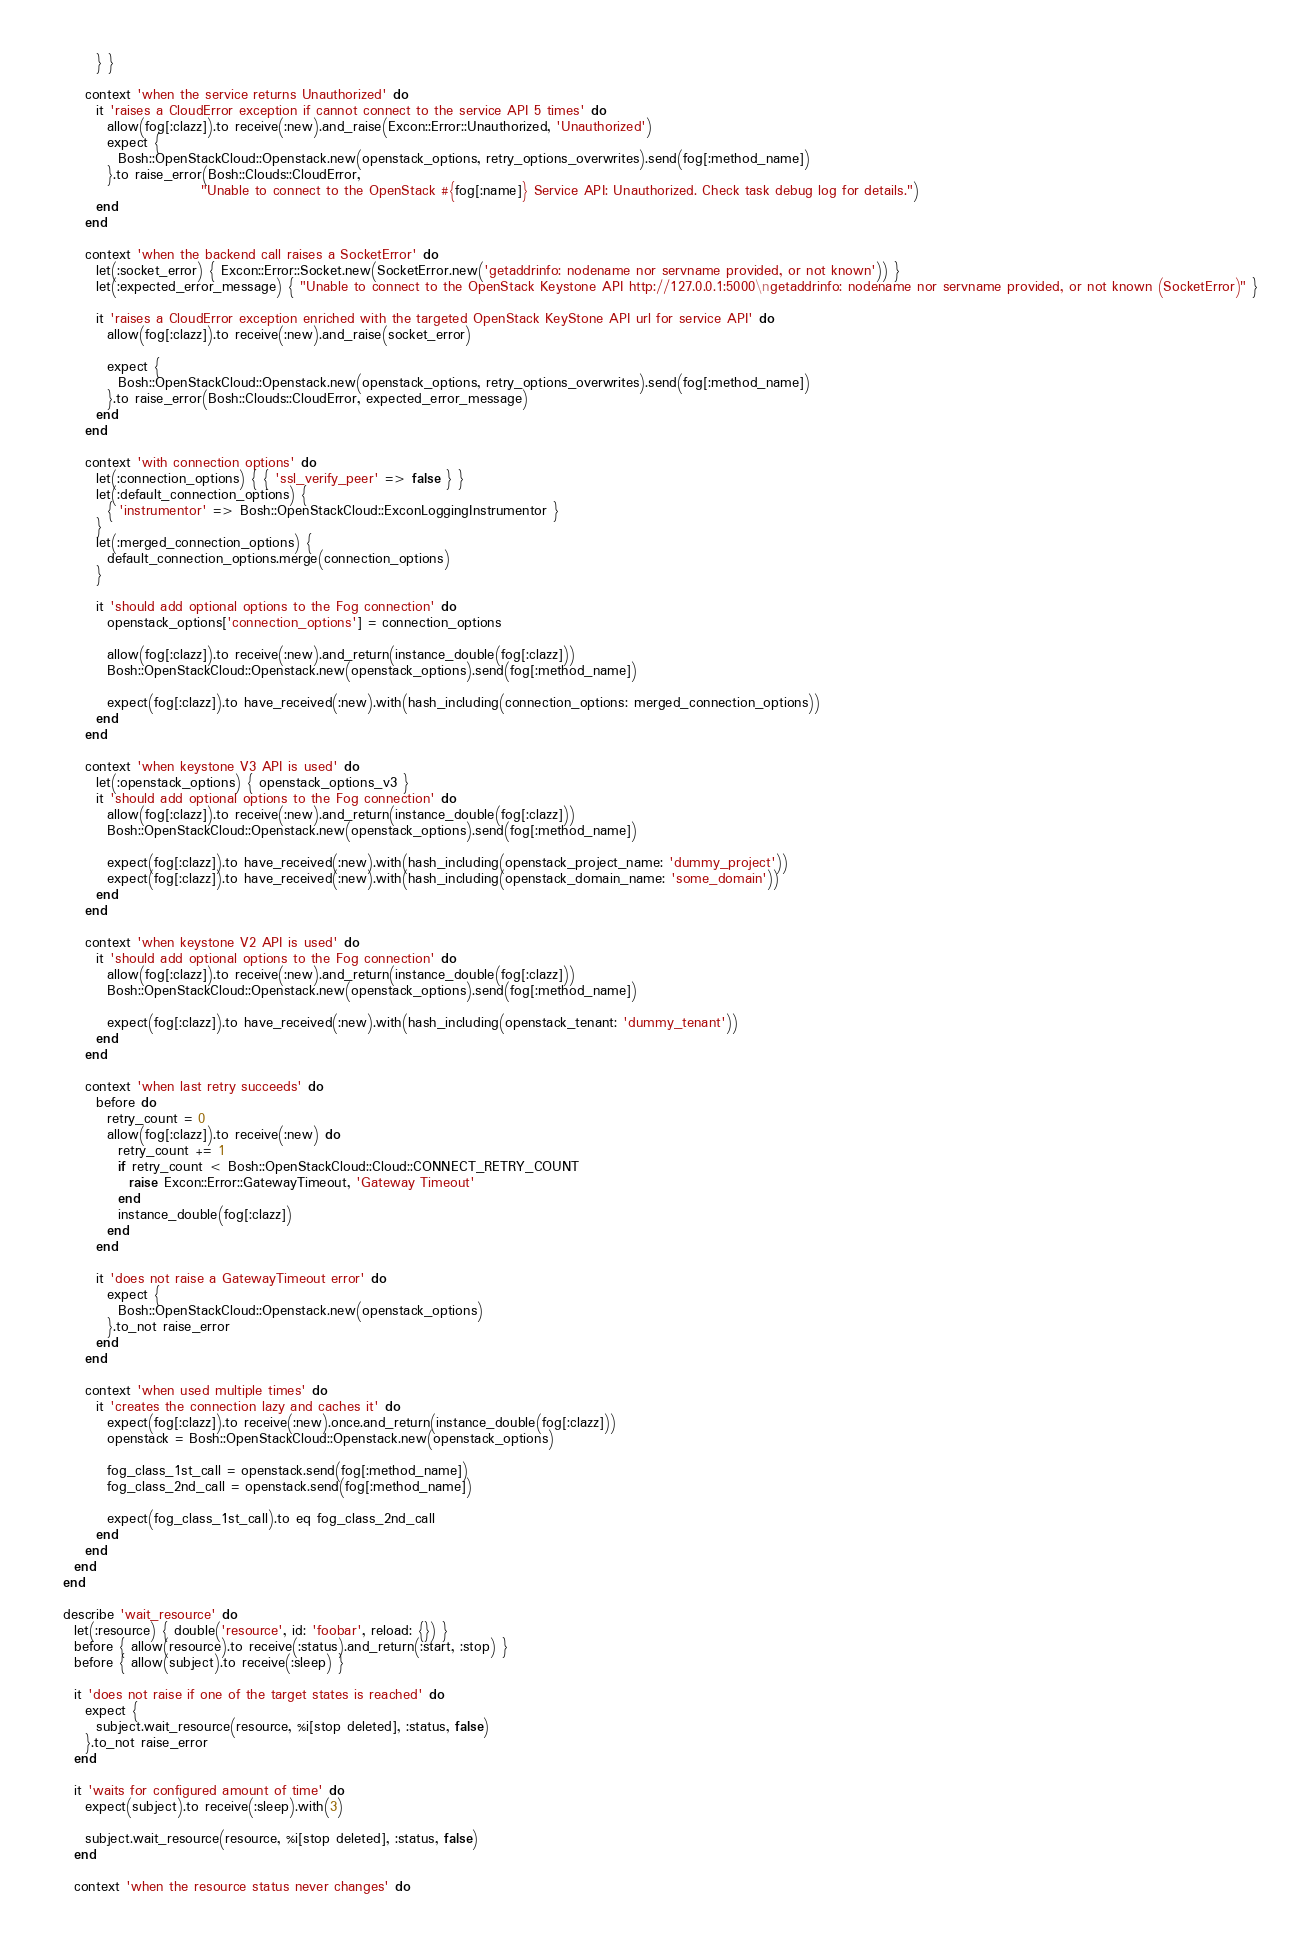Convert code to text. <code><loc_0><loc_0><loc_500><loc_500><_Ruby_>        } }

      context 'when the service returns Unauthorized' do
        it 'raises a CloudError exception if cannot connect to the service API 5 times' do
          allow(fog[:clazz]).to receive(:new).and_raise(Excon::Error::Unauthorized, 'Unauthorized')
          expect {
            Bosh::OpenStackCloud::Openstack.new(openstack_options, retry_options_overwrites).send(fog[:method_name])
          }.to raise_error(Bosh::Clouds::CloudError,
                           "Unable to connect to the OpenStack #{fog[:name]} Service API: Unauthorized. Check task debug log for details.")
        end
      end

      context 'when the backend call raises a SocketError' do
        let(:socket_error) { Excon::Error::Socket.new(SocketError.new('getaddrinfo: nodename nor servname provided, or not known')) }
        let(:expected_error_message) { "Unable to connect to the OpenStack Keystone API http://127.0.0.1:5000\ngetaddrinfo: nodename nor servname provided, or not known (SocketError)" }

        it 'raises a CloudError exception enriched with the targeted OpenStack KeyStone API url for service API' do
          allow(fog[:clazz]).to receive(:new).and_raise(socket_error)

          expect {
            Bosh::OpenStackCloud::Openstack.new(openstack_options, retry_options_overwrites).send(fog[:method_name])
          }.to raise_error(Bosh::Clouds::CloudError, expected_error_message)
        end
      end

      context 'with connection options' do
        let(:connection_options) { { 'ssl_verify_peer' => false } }
        let(:default_connection_options) {
          { 'instrumentor' => Bosh::OpenStackCloud::ExconLoggingInstrumentor }
        }
        let(:merged_connection_options) {
          default_connection_options.merge(connection_options)
        }

        it 'should add optional options to the Fog connection' do
          openstack_options['connection_options'] = connection_options

          allow(fog[:clazz]).to receive(:new).and_return(instance_double(fog[:clazz]))
          Bosh::OpenStackCloud::Openstack.new(openstack_options).send(fog[:method_name])

          expect(fog[:clazz]).to have_received(:new).with(hash_including(connection_options: merged_connection_options))
        end
      end

      context 'when keystone V3 API is used' do
        let(:openstack_options) { openstack_options_v3 }
        it 'should add optional options to the Fog connection' do
          allow(fog[:clazz]).to receive(:new).and_return(instance_double(fog[:clazz]))
          Bosh::OpenStackCloud::Openstack.new(openstack_options).send(fog[:method_name])

          expect(fog[:clazz]).to have_received(:new).with(hash_including(openstack_project_name: 'dummy_project'))
          expect(fog[:clazz]).to have_received(:new).with(hash_including(openstack_domain_name: 'some_domain'))
        end
      end

      context 'when keystone V2 API is used' do
        it 'should add optional options to the Fog connection' do
          allow(fog[:clazz]).to receive(:new).and_return(instance_double(fog[:clazz]))
          Bosh::OpenStackCloud::Openstack.new(openstack_options).send(fog[:method_name])

          expect(fog[:clazz]).to have_received(:new).with(hash_including(openstack_tenant: 'dummy_tenant'))
        end
      end

      context 'when last retry succeeds' do
        before do
          retry_count = 0
          allow(fog[:clazz]).to receive(:new) do
            retry_count += 1
            if retry_count < Bosh::OpenStackCloud::Cloud::CONNECT_RETRY_COUNT
              raise Excon::Error::GatewayTimeout, 'Gateway Timeout'
            end
            instance_double(fog[:clazz])
          end
        end

        it 'does not raise a GatewayTimeout error' do
          expect {
            Bosh::OpenStackCloud::Openstack.new(openstack_options)
          }.to_not raise_error
        end
      end

      context 'when used multiple times' do
        it 'creates the connection lazy and caches it' do
          expect(fog[:clazz]).to receive(:new).once.and_return(instance_double(fog[:clazz]))
          openstack = Bosh::OpenStackCloud::Openstack.new(openstack_options)

          fog_class_1st_call = openstack.send(fog[:method_name])
          fog_class_2nd_call = openstack.send(fog[:method_name])

          expect(fog_class_1st_call).to eq fog_class_2nd_call
        end
      end
    end
  end

  describe 'wait_resource' do
    let(:resource) { double('resource', id: 'foobar', reload: {}) }
    before { allow(resource).to receive(:status).and_return(:start, :stop) }
    before { allow(subject).to receive(:sleep) }

    it 'does not raise if one of the target states is reached' do
      expect {
        subject.wait_resource(resource, %i[stop deleted], :status, false)
      }.to_not raise_error
    end

    it 'waits for configured amount of time' do
      expect(subject).to receive(:sleep).with(3)

      subject.wait_resource(resource, %i[stop deleted], :status, false)
    end

    context 'when the resource status never changes' do</code> 